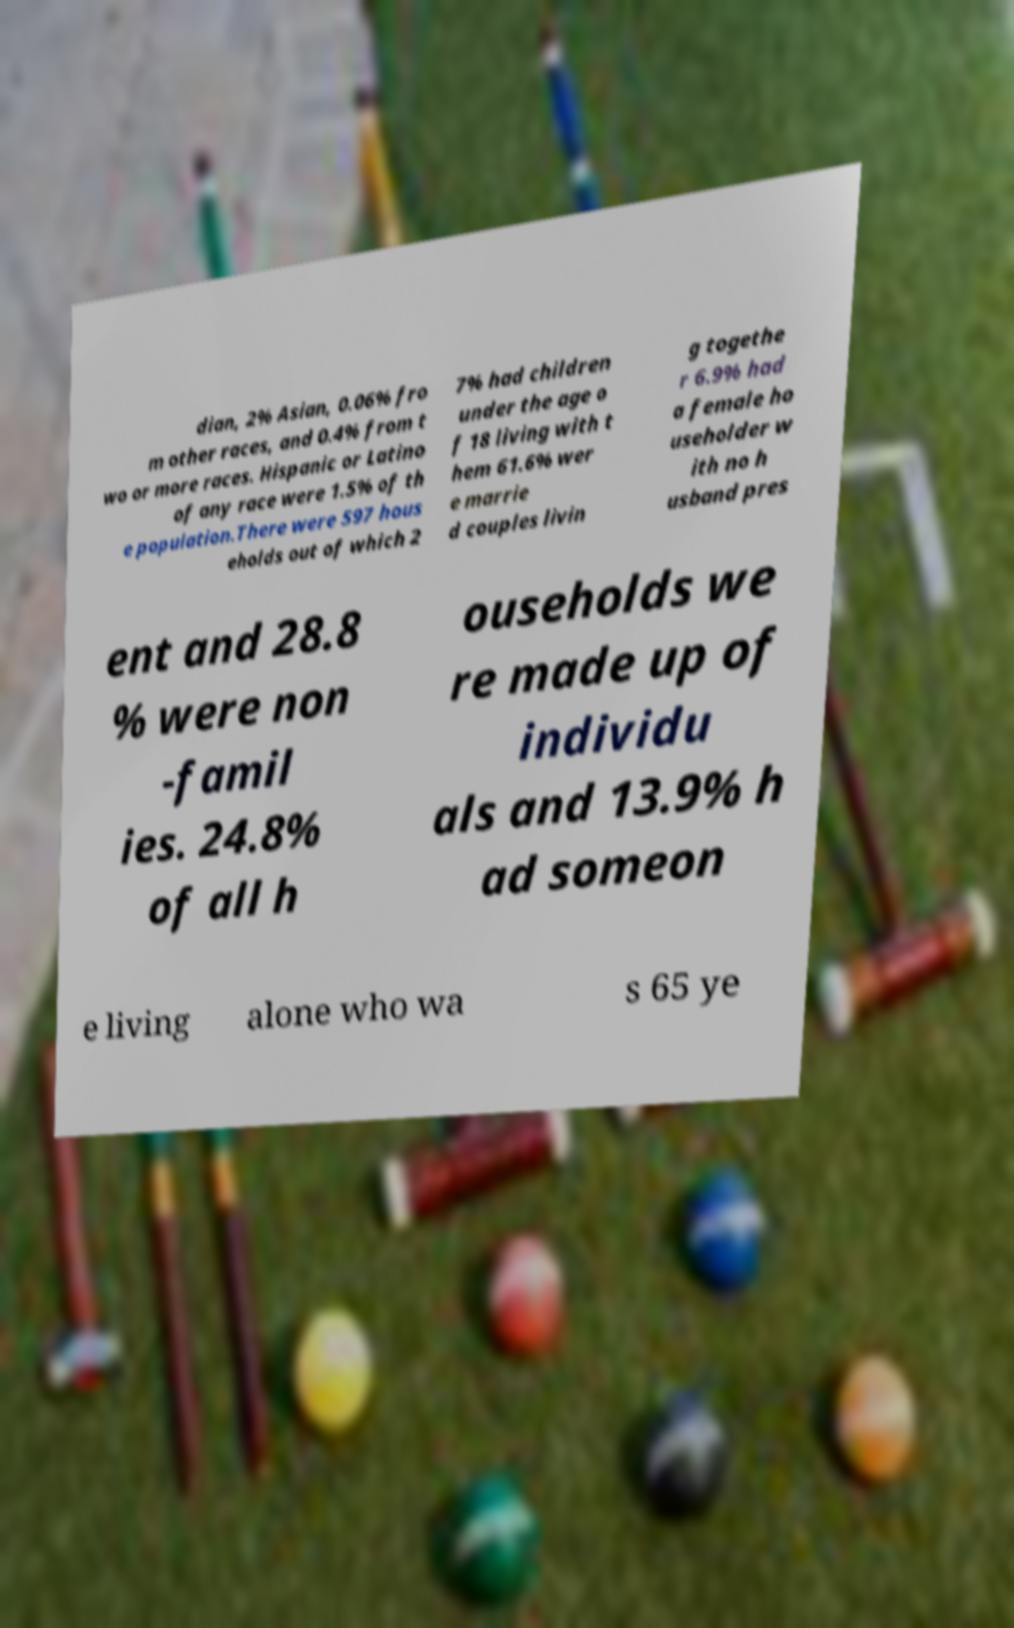There's text embedded in this image that I need extracted. Can you transcribe it verbatim? dian, 2% Asian, 0.06% fro m other races, and 0.4% from t wo or more races. Hispanic or Latino of any race were 1.5% of th e population.There were 597 hous eholds out of which 2 7% had children under the age o f 18 living with t hem 61.6% wer e marrie d couples livin g togethe r 6.9% had a female ho useholder w ith no h usband pres ent and 28.8 % were non -famil ies. 24.8% of all h ouseholds we re made up of individu als and 13.9% h ad someon e living alone who wa s 65 ye 